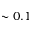Convert formula to latex. <formula><loc_0><loc_0><loc_500><loc_500>\sim 0 . 1</formula> 